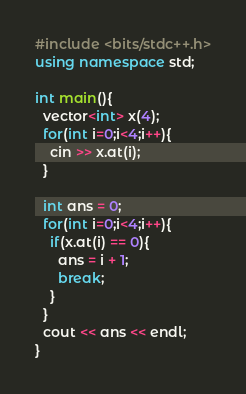<code> <loc_0><loc_0><loc_500><loc_500><_C++_>#include <bits/stdc++.h>
using namespace std;

int main(){
  vector<int> x(4);
  for(int i=0;i<4;i++){
    cin >> x.at(i);
  }
  
  int ans = 0;
  for(int i=0;i<4;i++){
    if(x.at(i) == 0){
      ans = i + 1;
      break;
    }
  }
  cout << ans << endl;
}</code> 